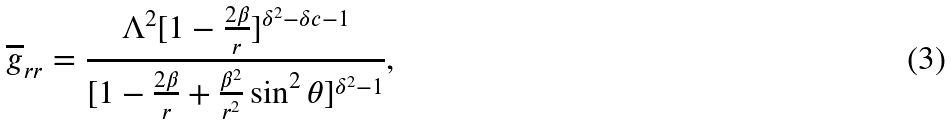Convert formula to latex. <formula><loc_0><loc_0><loc_500><loc_500>\overline { g } _ { r r } = \frac { \Lambda ^ { 2 } [ 1 - \frac { 2 \beta } { r } ] ^ { \delta ^ { 2 } - \delta c - 1 } } { [ 1 - \frac { 2 \beta } { r } + \frac { \beta ^ { 2 } } { r ^ { 2 } } \sin ^ { 2 } \theta ] ^ { \delta ^ { 2 } - 1 } } ,</formula> 